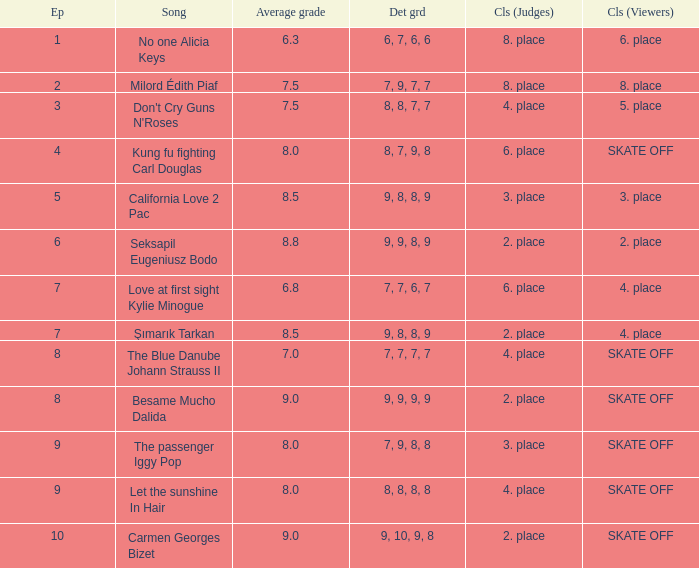Name the classification for 9, 9, 8, 9 2. place. 